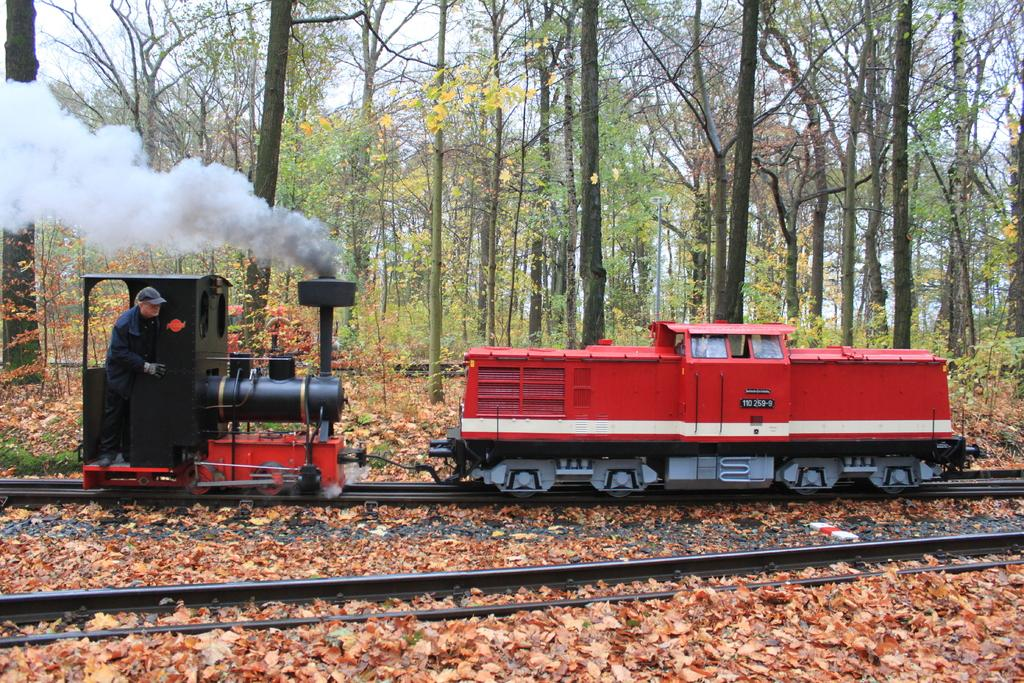What is the person in the image doing? The person is in a train in the image. What is the train situated on? The train is on a railway track. What can be seen in the background of the image? There are trees and sky visible in the background of the image. What is present at the bottom of the image? There are leaves at the bottom of the image. How many people are walking on the sidewalk in the image? There is no sidewalk present in the image, as it features a person in a train on a railway track. 